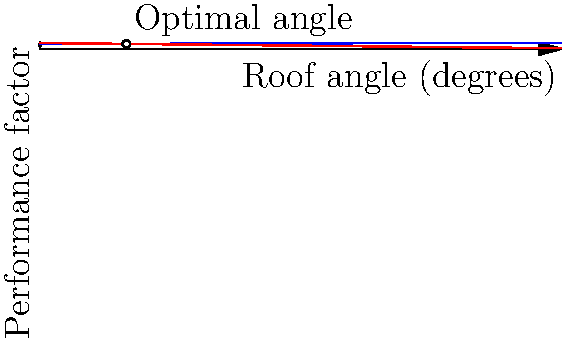As a digital marketing agency owner, you're working on a campaign for a roofing company. The client wants to emphasize the scientific approach they use in determining optimal roof angles. Based on the graph showing the relationship between roof angle, water runoff efficiency, and wind resistance, what is the optimal roof angle that balances both factors? To determine the optimal roof angle, we need to analyze the graph and find the intersection point of the two curves:

1. The blue curve represents water runoff efficiency, which increases with the roof angle.
2. The red curve represents wind resistance, which decreases as the roof angle increases.

The optimal angle is where these two factors are balanced, which occurs at the intersection point of the two curves. To find this point:

1. Observe that the blue curve (water runoff) is represented by the function:
   $$f_1(x) = 0.8 + 0.2 \sin(\frac{\pi x}{180})$$

2. The red curve (wind resistance) is represented by the function:
   $$f_2(x) = 1 - 0.01x$$

3. The intersection point is where $f_1(x) = f_2(x)$. Solving this equation:

   $$0.8 + 0.2 \sin(\frac{\pi x}{180}) = 1 - 0.01x$$

4. While the exact solution requires numerical methods, we can visually estimate from the graph that the intersection occurs at approximately 30 degrees.

This angle provides the best balance between water runoff efficiency and wind resistance, making it the optimal choice for the roof design.
Answer: Approximately 30 degrees 